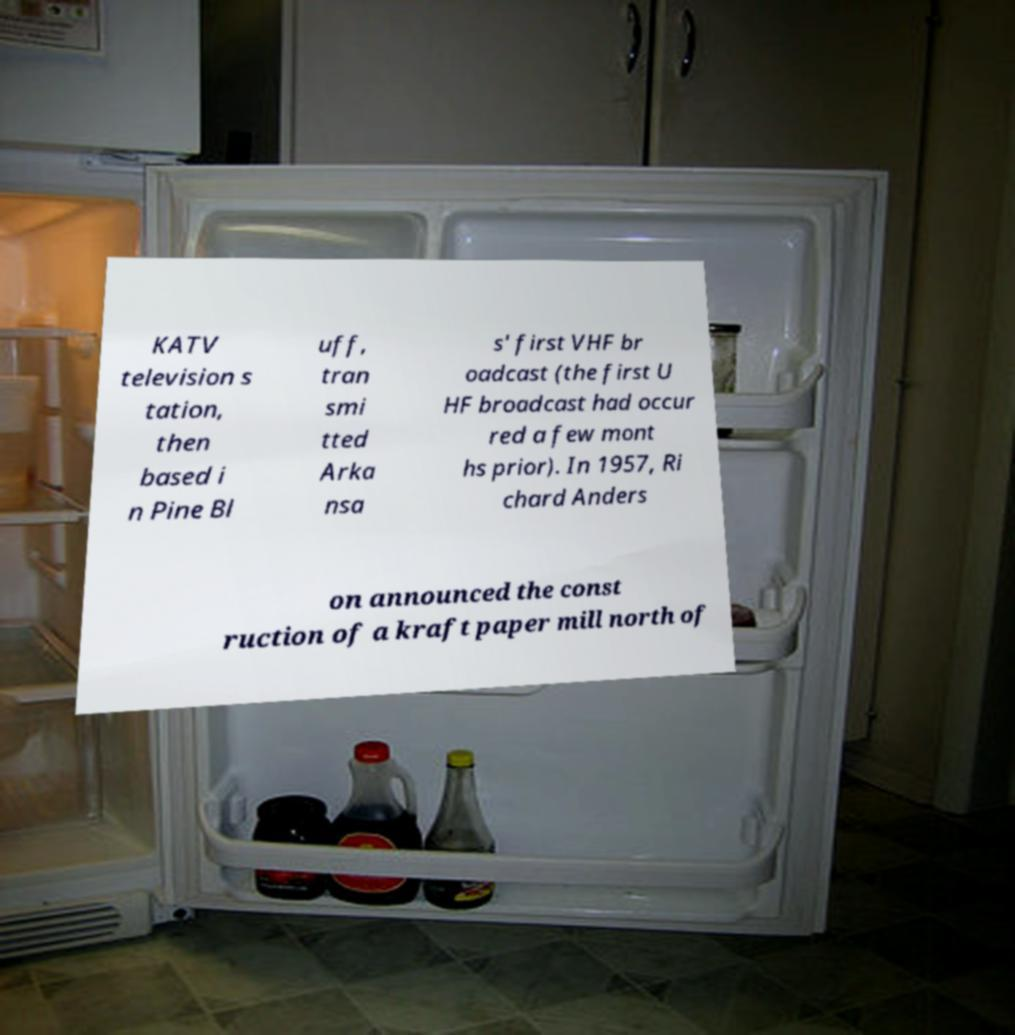There's text embedded in this image that I need extracted. Can you transcribe it verbatim? KATV television s tation, then based i n Pine Bl uff, tran smi tted Arka nsa s' first VHF br oadcast (the first U HF broadcast had occur red a few mont hs prior). In 1957, Ri chard Anders on announced the const ruction of a kraft paper mill north of 